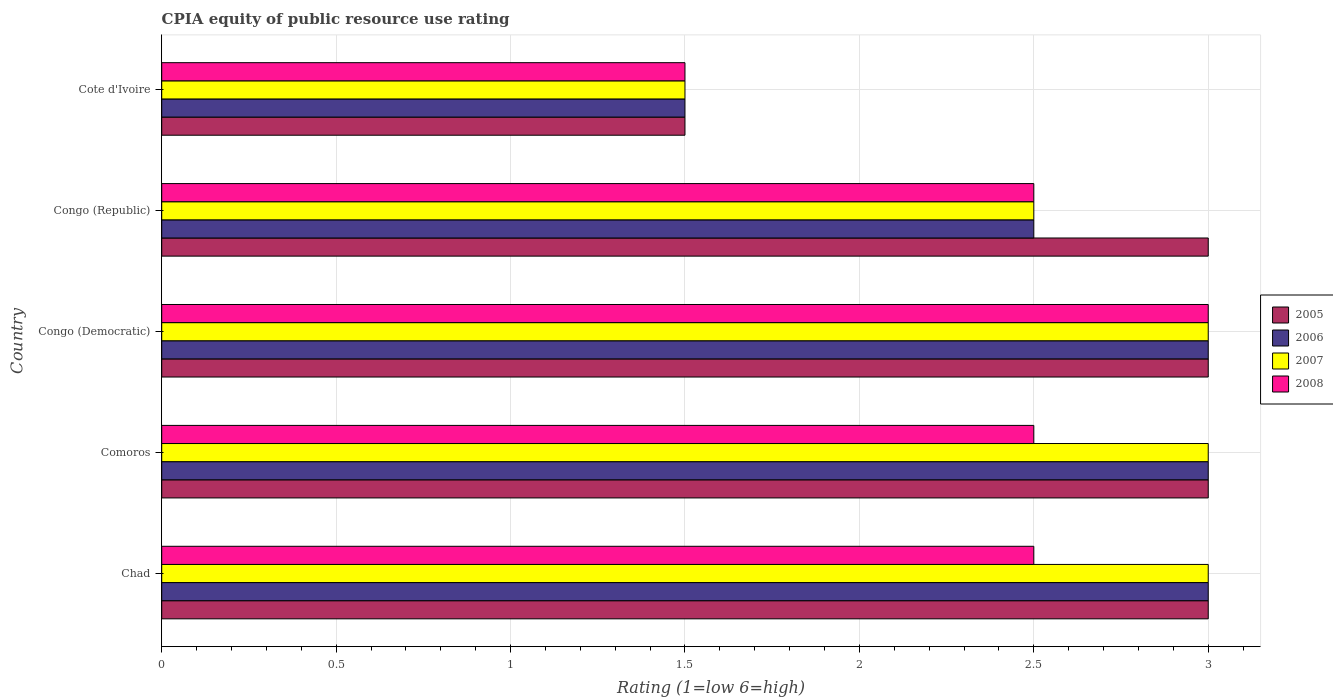How many different coloured bars are there?
Provide a short and direct response. 4. Are the number of bars on each tick of the Y-axis equal?
Offer a terse response. Yes. How many bars are there on the 3rd tick from the top?
Keep it short and to the point. 4. What is the label of the 2nd group of bars from the top?
Provide a succinct answer. Congo (Republic). In how many cases, is the number of bars for a given country not equal to the number of legend labels?
Keep it short and to the point. 0. Across all countries, what is the maximum CPIA rating in 2006?
Give a very brief answer. 3. Across all countries, what is the minimum CPIA rating in 2007?
Your answer should be very brief. 1.5. In which country was the CPIA rating in 2008 maximum?
Your response must be concise. Congo (Democratic). In which country was the CPIA rating in 2006 minimum?
Provide a succinct answer. Cote d'Ivoire. What is the difference between the CPIA rating in 2006 in Chad and the CPIA rating in 2007 in Cote d'Ivoire?
Make the answer very short. 1.5. What is the average CPIA rating in 2006 per country?
Give a very brief answer. 2.6. In how many countries, is the CPIA rating in 2007 greater than 0.2 ?
Make the answer very short. 5. What is the ratio of the CPIA rating in 2005 in Congo (Democratic) to that in Cote d'Ivoire?
Your response must be concise. 2. Is the CPIA rating in 2008 in Chad less than that in Cote d'Ivoire?
Provide a short and direct response. No. What is the difference between the highest and the lowest CPIA rating in 2007?
Your response must be concise. 1.5. In how many countries, is the CPIA rating in 2005 greater than the average CPIA rating in 2005 taken over all countries?
Offer a terse response. 4. Is the sum of the CPIA rating in 2006 in Comoros and Congo (Republic) greater than the maximum CPIA rating in 2005 across all countries?
Provide a short and direct response. Yes. What does the 4th bar from the top in Cote d'Ivoire represents?
Keep it short and to the point. 2005. What does the 4th bar from the bottom in Comoros represents?
Provide a succinct answer. 2008. How many countries are there in the graph?
Your answer should be very brief. 5. Does the graph contain any zero values?
Your answer should be compact. No. Where does the legend appear in the graph?
Provide a short and direct response. Center right. How many legend labels are there?
Ensure brevity in your answer.  4. What is the title of the graph?
Make the answer very short. CPIA equity of public resource use rating. Does "2012" appear as one of the legend labels in the graph?
Make the answer very short. No. What is the Rating (1=low 6=high) in 2005 in Chad?
Give a very brief answer. 3. What is the Rating (1=low 6=high) of 2006 in Chad?
Your response must be concise. 3. What is the Rating (1=low 6=high) in 2007 in Chad?
Your answer should be very brief. 3. What is the Rating (1=low 6=high) in 2008 in Chad?
Offer a terse response. 2.5. What is the Rating (1=low 6=high) in 2005 in Comoros?
Your response must be concise. 3. What is the Rating (1=low 6=high) of 2005 in Congo (Democratic)?
Your answer should be compact. 3. What is the Rating (1=low 6=high) in 2006 in Congo (Republic)?
Provide a succinct answer. 2.5. What is the Rating (1=low 6=high) of 2006 in Cote d'Ivoire?
Your answer should be compact. 1.5. Across all countries, what is the minimum Rating (1=low 6=high) of 2005?
Your response must be concise. 1.5. Across all countries, what is the minimum Rating (1=low 6=high) of 2006?
Provide a succinct answer. 1.5. Across all countries, what is the minimum Rating (1=low 6=high) of 2008?
Your answer should be compact. 1.5. What is the total Rating (1=low 6=high) of 2005 in the graph?
Give a very brief answer. 13.5. What is the total Rating (1=low 6=high) in 2006 in the graph?
Keep it short and to the point. 13. What is the total Rating (1=low 6=high) in 2007 in the graph?
Your answer should be very brief. 13. What is the total Rating (1=low 6=high) in 2008 in the graph?
Give a very brief answer. 12. What is the difference between the Rating (1=low 6=high) in 2005 in Chad and that in Comoros?
Make the answer very short. 0. What is the difference between the Rating (1=low 6=high) in 2006 in Chad and that in Comoros?
Give a very brief answer. 0. What is the difference between the Rating (1=low 6=high) of 2007 in Chad and that in Comoros?
Provide a short and direct response. 0. What is the difference between the Rating (1=low 6=high) in 2008 in Chad and that in Comoros?
Your answer should be compact. 0. What is the difference between the Rating (1=low 6=high) of 2005 in Chad and that in Congo (Democratic)?
Offer a terse response. 0. What is the difference between the Rating (1=low 6=high) in 2005 in Chad and that in Congo (Republic)?
Make the answer very short. 0. What is the difference between the Rating (1=low 6=high) in 2006 in Chad and that in Congo (Republic)?
Provide a short and direct response. 0.5. What is the difference between the Rating (1=low 6=high) in 2005 in Chad and that in Cote d'Ivoire?
Give a very brief answer. 1.5. What is the difference between the Rating (1=low 6=high) in 2006 in Chad and that in Cote d'Ivoire?
Keep it short and to the point. 1.5. What is the difference between the Rating (1=low 6=high) in 2007 in Chad and that in Cote d'Ivoire?
Provide a succinct answer. 1.5. What is the difference between the Rating (1=low 6=high) in 2008 in Chad and that in Cote d'Ivoire?
Ensure brevity in your answer.  1. What is the difference between the Rating (1=low 6=high) of 2005 in Comoros and that in Congo (Democratic)?
Your answer should be compact. 0. What is the difference between the Rating (1=low 6=high) in 2006 in Comoros and that in Congo (Democratic)?
Give a very brief answer. 0. What is the difference between the Rating (1=low 6=high) of 2007 in Comoros and that in Congo (Democratic)?
Your answer should be compact. 0. What is the difference between the Rating (1=low 6=high) in 2006 in Comoros and that in Congo (Republic)?
Ensure brevity in your answer.  0.5. What is the difference between the Rating (1=low 6=high) of 2008 in Comoros and that in Congo (Republic)?
Ensure brevity in your answer.  0. What is the difference between the Rating (1=low 6=high) in 2005 in Comoros and that in Cote d'Ivoire?
Your response must be concise. 1.5. What is the difference between the Rating (1=low 6=high) in 2007 in Comoros and that in Cote d'Ivoire?
Provide a succinct answer. 1.5. What is the difference between the Rating (1=low 6=high) in 2005 in Congo (Democratic) and that in Congo (Republic)?
Offer a terse response. 0. What is the difference between the Rating (1=low 6=high) of 2006 in Congo (Democratic) and that in Congo (Republic)?
Ensure brevity in your answer.  0.5. What is the difference between the Rating (1=low 6=high) of 2008 in Congo (Democratic) and that in Congo (Republic)?
Your answer should be very brief. 0.5. What is the difference between the Rating (1=low 6=high) in 2006 in Congo (Democratic) and that in Cote d'Ivoire?
Provide a short and direct response. 1.5. What is the difference between the Rating (1=low 6=high) in 2007 in Congo (Republic) and that in Cote d'Ivoire?
Provide a short and direct response. 1. What is the difference between the Rating (1=low 6=high) in 2008 in Congo (Republic) and that in Cote d'Ivoire?
Give a very brief answer. 1. What is the difference between the Rating (1=low 6=high) in 2005 in Chad and the Rating (1=low 6=high) in 2006 in Comoros?
Your response must be concise. 0. What is the difference between the Rating (1=low 6=high) of 2006 in Chad and the Rating (1=low 6=high) of 2007 in Comoros?
Your response must be concise. 0. What is the difference between the Rating (1=low 6=high) of 2006 in Chad and the Rating (1=low 6=high) of 2008 in Comoros?
Keep it short and to the point. 0.5. What is the difference between the Rating (1=low 6=high) in 2005 in Chad and the Rating (1=low 6=high) in 2006 in Congo (Democratic)?
Make the answer very short. 0. What is the difference between the Rating (1=low 6=high) in 2005 in Chad and the Rating (1=low 6=high) in 2008 in Congo (Democratic)?
Keep it short and to the point. 0. What is the difference between the Rating (1=low 6=high) of 2007 in Chad and the Rating (1=low 6=high) of 2008 in Congo (Democratic)?
Your answer should be compact. 0. What is the difference between the Rating (1=low 6=high) in 2005 in Chad and the Rating (1=low 6=high) in 2006 in Congo (Republic)?
Your response must be concise. 0.5. What is the difference between the Rating (1=low 6=high) of 2005 in Chad and the Rating (1=low 6=high) of 2007 in Congo (Republic)?
Offer a very short reply. 0.5. What is the difference between the Rating (1=low 6=high) in 2005 in Chad and the Rating (1=low 6=high) in 2008 in Congo (Republic)?
Offer a very short reply. 0.5. What is the difference between the Rating (1=low 6=high) in 2005 in Chad and the Rating (1=low 6=high) in 2008 in Cote d'Ivoire?
Your answer should be compact. 1.5. What is the difference between the Rating (1=low 6=high) of 2006 in Chad and the Rating (1=low 6=high) of 2008 in Cote d'Ivoire?
Make the answer very short. 1.5. What is the difference between the Rating (1=low 6=high) in 2005 in Comoros and the Rating (1=low 6=high) in 2006 in Congo (Democratic)?
Ensure brevity in your answer.  0. What is the difference between the Rating (1=low 6=high) in 2005 in Comoros and the Rating (1=low 6=high) in 2006 in Congo (Republic)?
Keep it short and to the point. 0.5. What is the difference between the Rating (1=low 6=high) of 2006 in Comoros and the Rating (1=low 6=high) of 2007 in Congo (Republic)?
Your answer should be compact. 0.5. What is the difference between the Rating (1=low 6=high) of 2007 in Comoros and the Rating (1=low 6=high) of 2008 in Congo (Republic)?
Your answer should be compact. 0.5. What is the difference between the Rating (1=low 6=high) of 2005 in Comoros and the Rating (1=low 6=high) of 2006 in Cote d'Ivoire?
Your answer should be very brief. 1.5. What is the difference between the Rating (1=low 6=high) of 2005 in Comoros and the Rating (1=low 6=high) of 2007 in Cote d'Ivoire?
Your response must be concise. 1.5. What is the difference between the Rating (1=low 6=high) in 2005 in Comoros and the Rating (1=low 6=high) in 2008 in Cote d'Ivoire?
Provide a succinct answer. 1.5. What is the difference between the Rating (1=low 6=high) in 2006 in Comoros and the Rating (1=low 6=high) in 2007 in Cote d'Ivoire?
Offer a terse response. 1.5. What is the difference between the Rating (1=low 6=high) in 2005 in Congo (Democratic) and the Rating (1=low 6=high) in 2007 in Congo (Republic)?
Your answer should be compact. 0.5. What is the difference between the Rating (1=low 6=high) in 2006 in Congo (Democratic) and the Rating (1=low 6=high) in 2008 in Congo (Republic)?
Keep it short and to the point. 0.5. What is the difference between the Rating (1=low 6=high) of 2007 in Congo (Democratic) and the Rating (1=low 6=high) of 2008 in Congo (Republic)?
Your answer should be very brief. 0.5. What is the difference between the Rating (1=low 6=high) in 2005 in Congo (Democratic) and the Rating (1=low 6=high) in 2007 in Cote d'Ivoire?
Your answer should be very brief. 1.5. What is the difference between the Rating (1=low 6=high) in 2006 in Congo (Democratic) and the Rating (1=low 6=high) in 2008 in Cote d'Ivoire?
Make the answer very short. 1.5. What is the difference between the Rating (1=low 6=high) in 2005 in Congo (Republic) and the Rating (1=low 6=high) in 2006 in Cote d'Ivoire?
Keep it short and to the point. 1.5. What is the difference between the Rating (1=low 6=high) of 2005 in Congo (Republic) and the Rating (1=low 6=high) of 2008 in Cote d'Ivoire?
Offer a terse response. 1.5. What is the difference between the Rating (1=low 6=high) of 2006 in Congo (Republic) and the Rating (1=low 6=high) of 2007 in Cote d'Ivoire?
Offer a very short reply. 1. What is the difference between the Rating (1=low 6=high) of 2006 in Congo (Republic) and the Rating (1=low 6=high) of 2008 in Cote d'Ivoire?
Provide a short and direct response. 1. What is the difference between the Rating (1=low 6=high) of 2007 in Congo (Republic) and the Rating (1=low 6=high) of 2008 in Cote d'Ivoire?
Your response must be concise. 1. What is the average Rating (1=low 6=high) in 2007 per country?
Give a very brief answer. 2.6. What is the average Rating (1=low 6=high) of 2008 per country?
Provide a succinct answer. 2.4. What is the difference between the Rating (1=low 6=high) of 2005 and Rating (1=low 6=high) of 2007 in Chad?
Ensure brevity in your answer.  0. What is the difference between the Rating (1=low 6=high) in 2005 and Rating (1=low 6=high) in 2008 in Chad?
Ensure brevity in your answer.  0.5. What is the difference between the Rating (1=low 6=high) of 2006 and Rating (1=low 6=high) of 2007 in Chad?
Provide a short and direct response. 0. What is the difference between the Rating (1=low 6=high) of 2006 and Rating (1=low 6=high) of 2008 in Chad?
Offer a very short reply. 0.5. What is the difference between the Rating (1=low 6=high) in 2006 and Rating (1=low 6=high) in 2007 in Comoros?
Your answer should be very brief. 0. What is the difference between the Rating (1=low 6=high) in 2005 and Rating (1=low 6=high) in 2007 in Congo (Democratic)?
Give a very brief answer. 0. What is the difference between the Rating (1=low 6=high) in 2005 and Rating (1=low 6=high) in 2008 in Congo (Democratic)?
Offer a terse response. 0. What is the difference between the Rating (1=low 6=high) in 2006 and Rating (1=low 6=high) in 2007 in Congo (Democratic)?
Provide a short and direct response. 0. What is the difference between the Rating (1=low 6=high) of 2006 and Rating (1=low 6=high) of 2008 in Congo (Democratic)?
Provide a succinct answer. 0. What is the difference between the Rating (1=low 6=high) of 2007 and Rating (1=low 6=high) of 2008 in Congo (Democratic)?
Provide a succinct answer. 0. What is the difference between the Rating (1=low 6=high) in 2005 and Rating (1=low 6=high) in 2006 in Congo (Republic)?
Your response must be concise. 0.5. What is the difference between the Rating (1=low 6=high) in 2005 and Rating (1=low 6=high) in 2007 in Congo (Republic)?
Ensure brevity in your answer.  0.5. What is the difference between the Rating (1=low 6=high) of 2005 and Rating (1=low 6=high) of 2008 in Congo (Republic)?
Provide a succinct answer. 0.5. What is the difference between the Rating (1=low 6=high) of 2006 and Rating (1=low 6=high) of 2007 in Congo (Republic)?
Ensure brevity in your answer.  0. What is the difference between the Rating (1=low 6=high) in 2007 and Rating (1=low 6=high) in 2008 in Congo (Republic)?
Give a very brief answer. 0. What is the difference between the Rating (1=low 6=high) of 2005 and Rating (1=low 6=high) of 2006 in Cote d'Ivoire?
Your answer should be compact. 0. What is the difference between the Rating (1=low 6=high) in 2005 and Rating (1=low 6=high) in 2008 in Cote d'Ivoire?
Ensure brevity in your answer.  0. What is the difference between the Rating (1=low 6=high) in 2006 and Rating (1=low 6=high) in 2008 in Cote d'Ivoire?
Provide a short and direct response. 0. What is the difference between the Rating (1=low 6=high) of 2007 and Rating (1=low 6=high) of 2008 in Cote d'Ivoire?
Offer a very short reply. 0. What is the ratio of the Rating (1=low 6=high) in 2005 in Chad to that in Comoros?
Your response must be concise. 1. What is the ratio of the Rating (1=low 6=high) of 2005 in Chad to that in Congo (Democratic)?
Keep it short and to the point. 1. What is the ratio of the Rating (1=low 6=high) in 2007 in Chad to that in Congo (Democratic)?
Provide a succinct answer. 1. What is the ratio of the Rating (1=low 6=high) in 2008 in Chad to that in Congo (Democratic)?
Your answer should be very brief. 0.83. What is the ratio of the Rating (1=low 6=high) of 2005 in Chad to that in Congo (Republic)?
Keep it short and to the point. 1. What is the ratio of the Rating (1=low 6=high) in 2007 in Chad to that in Congo (Republic)?
Provide a short and direct response. 1.2. What is the ratio of the Rating (1=low 6=high) of 2008 in Chad to that in Congo (Republic)?
Keep it short and to the point. 1. What is the ratio of the Rating (1=low 6=high) of 2005 in Chad to that in Cote d'Ivoire?
Offer a very short reply. 2. What is the ratio of the Rating (1=low 6=high) of 2006 in Chad to that in Cote d'Ivoire?
Provide a succinct answer. 2. What is the ratio of the Rating (1=low 6=high) in 2007 in Chad to that in Cote d'Ivoire?
Provide a succinct answer. 2. What is the ratio of the Rating (1=low 6=high) of 2005 in Comoros to that in Congo (Democratic)?
Provide a short and direct response. 1. What is the ratio of the Rating (1=low 6=high) in 2007 in Comoros to that in Congo (Democratic)?
Your answer should be very brief. 1. What is the ratio of the Rating (1=low 6=high) in 2008 in Comoros to that in Congo (Democratic)?
Keep it short and to the point. 0.83. What is the ratio of the Rating (1=low 6=high) in 2005 in Comoros to that in Congo (Republic)?
Your answer should be compact. 1. What is the ratio of the Rating (1=low 6=high) in 2006 in Comoros to that in Congo (Republic)?
Keep it short and to the point. 1.2. What is the ratio of the Rating (1=low 6=high) of 2007 in Comoros to that in Congo (Republic)?
Provide a short and direct response. 1.2. What is the ratio of the Rating (1=low 6=high) of 2008 in Comoros to that in Congo (Republic)?
Give a very brief answer. 1. What is the ratio of the Rating (1=low 6=high) in 2005 in Comoros to that in Cote d'Ivoire?
Offer a very short reply. 2. What is the ratio of the Rating (1=low 6=high) of 2008 in Comoros to that in Cote d'Ivoire?
Your answer should be compact. 1.67. What is the ratio of the Rating (1=low 6=high) of 2006 in Congo (Democratic) to that in Congo (Republic)?
Offer a very short reply. 1.2. What is the ratio of the Rating (1=low 6=high) in 2008 in Congo (Democratic) to that in Congo (Republic)?
Offer a terse response. 1.2. What is the ratio of the Rating (1=low 6=high) of 2008 in Congo (Democratic) to that in Cote d'Ivoire?
Your answer should be very brief. 2. What is the ratio of the Rating (1=low 6=high) in 2005 in Congo (Republic) to that in Cote d'Ivoire?
Make the answer very short. 2. What is the ratio of the Rating (1=low 6=high) of 2006 in Congo (Republic) to that in Cote d'Ivoire?
Offer a terse response. 1.67. What is the ratio of the Rating (1=low 6=high) in 2007 in Congo (Republic) to that in Cote d'Ivoire?
Your answer should be compact. 1.67. What is the ratio of the Rating (1=low 6=high) in 2008 in Congo (Republic) to that in Cote d'Ivoire?
Give a very brief answer. 1.67. What is the difference between the highest and the lowest Rating (1=low 6=high) of 2005?
Keep it short and to the point. 1.5. What is the difference between the highest and the lowest Rating (1=low 6=high) in 2006?
Your answer should be compact. 1.5. What is the difference between the highest and the lowest Rating (1=low 6=high) of 2007?
Offer a terse response. 1.5. What is the difference between the highest and the lowest Rating (1=low 6=high) of 2008?
Provide a succinct answer. 1.5. 